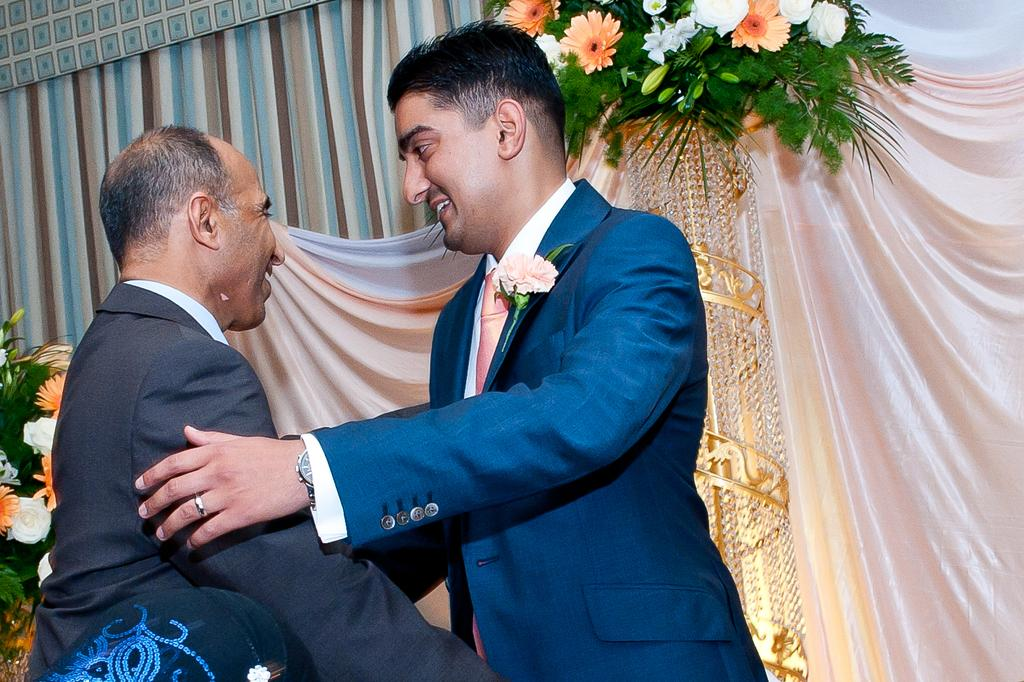How many men are present in the image? There are two men standing in the image. What are the men wearing? Both men are wearing clothes. Can you describe any accessories worn by the men? The man on the right side is wearing a wrist watch and a finger ring. What else can be seen in the image besides the men? There is a flower bouquet and curtains in the image. Are there any slaves depicted in the image? There is no mention of slaves or any related context in the image. What type of patch can be seen on the tramp's clothing in the image? There is no tramp or any clothing with patches present in the image. 